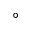<formula> <loc_0><loc_0><loc_500><loc_500>^ { \circ }</formula> 